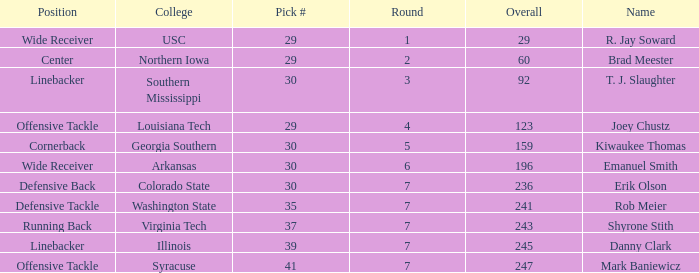Parse the full table. {'header': ['Position', 'College', 'Pick #', 'Round', 'Overall', 'Name'], 'rows': [['Wide Receiver', 'USC', '29', '1', '29', 'R. Jay Soward'], ['Center', 'Northern Iowa', '29', '2', '60', 'Brad Meester'], ['Linebacker', 'Southern Mississippi', '30', '3', '92', 'T. J. Slaughter'], ['Offensive Tackle', 'Louisiana Tech', '29', '4', '123', 'Joey Chustz'], ['Cornerback', 'Georgia Southern', '30', '5', '159', 'Kiwaukee Thomas'], ['Wide Receiver', 'Arkansas', '30', '6', '196', 'Emanuel Smith'], ['Defensive Back', 'Colorado State', '30', '7', '236', 'Erik Olson'], ['Defensive Tackle', 'Washington State', '35', '7', '241', 'Rob Meier'], ['Running Back', 'Virginia Tech', '37', '7', '243', 'Shyrone Stith'], ['Linebacker', 'Illinois', '39', '7', '245', 'Danny Clark'], ['Offensive Tackle', 'Syracuse', '41', '7', '247', 'Mark Baniewicz']]} What is the Position with a round 3 pick for r. jay soward? Wide Receiver. 